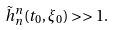<formula> <loc_0><loc_0><loc_500><loc_500>\tilde { h } ^ { n } _ { n } ( t _ { 0 } , \xi _ { 0 } ) > > 1 .</formula> 